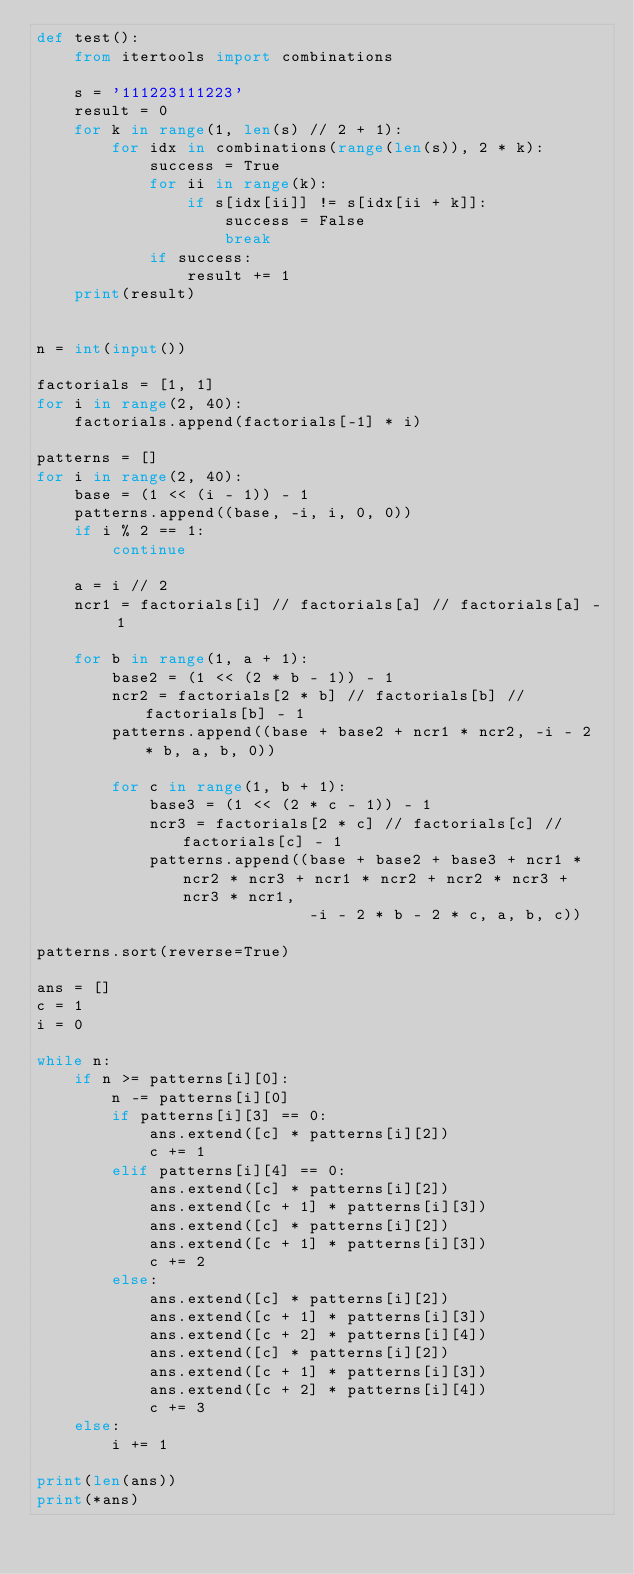<code> <loc_0><loc_0><loc_500><loc_500><_Python_>def test():
    from itertools import combinations

    s = '111223111223'
    result = 0
    for k in range(1, len(s) // 2 + 1):
        for idx in combinations(range(len(s)), 2 * k):
            success = True
            for ii in range(k):
                if s[idx[ii]] != s[idx[ii + k]]:
                    success = False
                    break
            if success:
                result += 1
    print(result)


n = int(input())

factorials = [1, 1]
for i in range(2, 40):
    factorials.append(factorials[-1] * i)

patterns = []
for i in range(2, 40):
    base = (1 << (i - 1)) - 1
    patterns.append((base, -i, i, 0, 0))
    if i % 2 == 1:
        continue

    a = i // 2
    ncr1 = factorials[i] // factorials[a] // factorials[a] - 1

    for b in range(1, a + 1):
        base2 = (1 << (2 * b - 1)) - 1
        ncr2 = factorials[2 * b] // factorials[b] // factorials[b] - 1
        patterns.append((base + base2 + ncr1 * ncr2, -i - 2 * b, a, b, 0))

        for c in range(1, b + 1):
            base3 = (1 << (2 * c - 1)) - 1
            ncr3 = factorials[2 * c] // factorials[c] // factorials[c] - 1
            patterns.append((base + base2 + base3 + ncr1 * ncr2 * ncr3 + ncr1 * ncr2 + ncr2 * ncr3 + ncr3 * ncr1,
                             -i - 2 * b - 2 * c, a, b, c))

patterns.sort(reverse=True)

ans = []
c = 1
i = 0

while n:
    if n >= patterns[i][0]:
        n -= patterns[i][0]
        if patterns[i][3] == 0:
            ans.extend([c] * patterns[i][2])
            c += 1
        elif patterns[i][4] == 0:
            ans.extend([c] * patterns[i][2])
            ans.extend([c + 1] * patterns[i][3])
            ans.extend([c] * patterns[i][2])
            ans.extend([c + 1] * patterns[i][3])
            c += 2
        else:
            ans.extend([c] * patterns[i][2])
            ans.extend([c + 1] * patterns[i][3])
            ans.extend([c + 2] * patterns[i][4])
            ans.extend([c] * patterns[i][2])
            ans.extend([c + 1] * patterns[i][3])
            ans.extend([c + 2] * patterns[i][4])
            c += 3
    else:
        i += 1

print(len(ans))
print(*ans)
</code> 